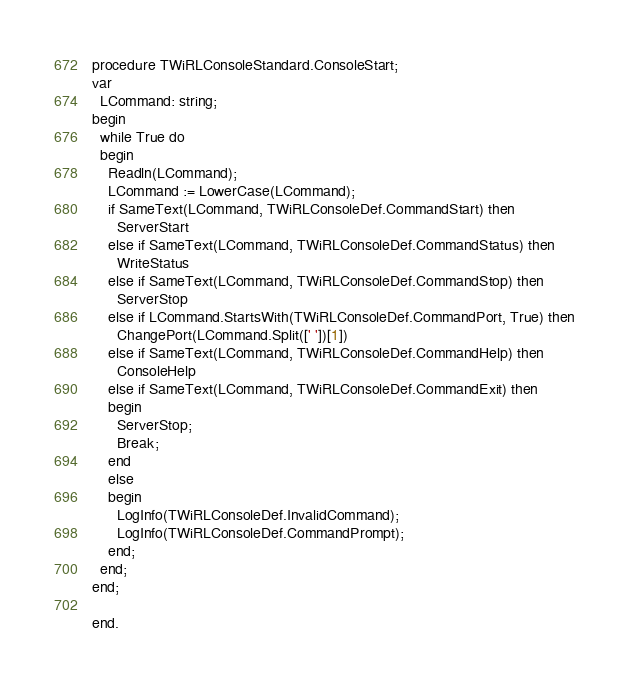<code> <loc_0><loc_0><loc_500><loc_500><_Pascal_>
procedure TWiRLConsoleStandard.ConsoleStart;
var
  LCommand: string;
begin
  while True do
  begin
    Readln(LCommand);
    LCommand := LowerCase(LCommand);
    if SameText(LCommand, TWiRLConsoleDef.CommandStart) then
      ServerStart
    else if SameText(LCommand, TWiRLConsoleDef.CommandStatus) then
      WriteStatus
    else if SameText(LCommand, TWiRLConsoleDef.CommandStop) then
      ServerStop
    else if LCommand.StartsWith(TWiRLConsoleDef.CommandPort, True) then
      ChangePort(LCommand.Split([' '])[1])
    else if SameText(LCommand, TWiRLConsoleDef.CommandHelp) then
      ConsoleHelp
    else if SameText(LCommand, TWiRLConsoleDef.CommandExit) then
    begin
      ServerStop;
      Break;
    end
    else
    begin
      LogInfo(TWiRLConsoleDef.InvalidCommand);
      LogInfo(TWiRLConsoleDef.CommandPrompt);
    end;
  end;
end;

end.
</code> 